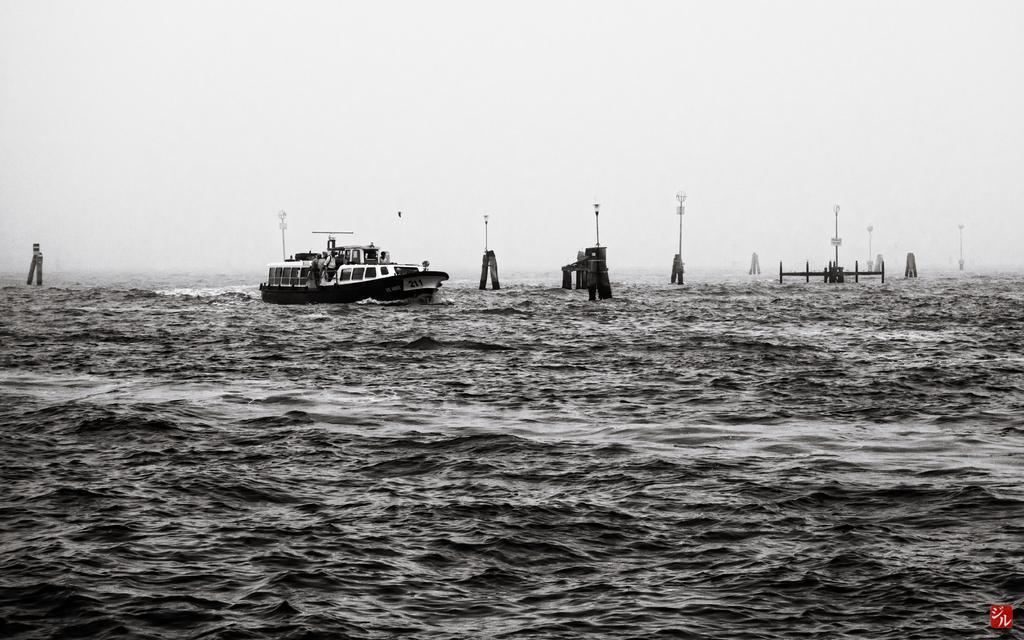Can you describe this image briefly? In this image we can see ship on the sea, pillars, poles, sky and water. 